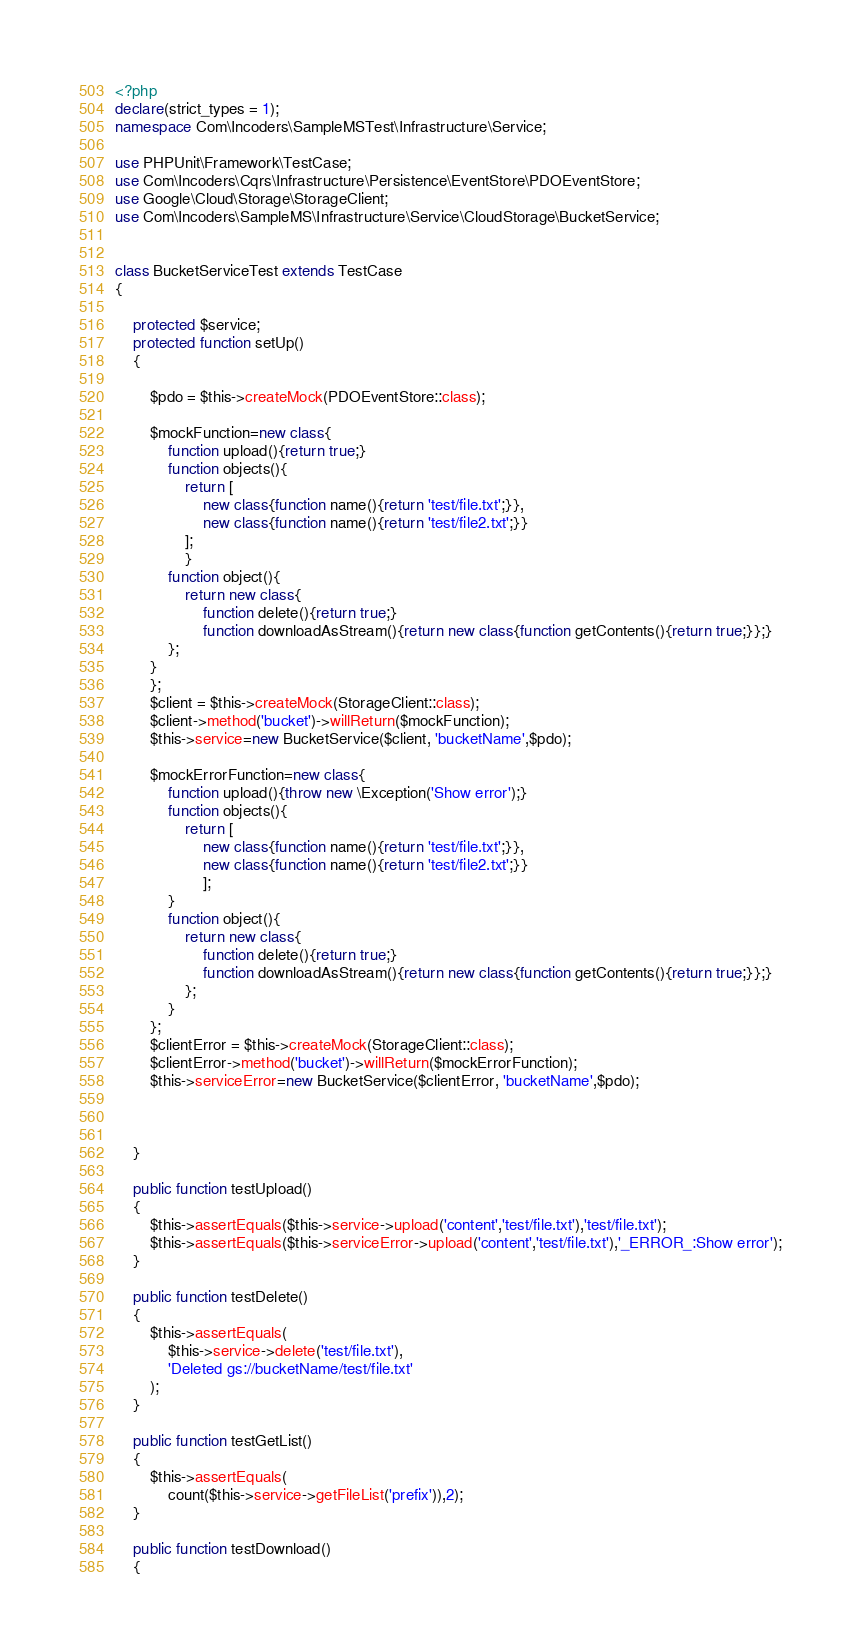<code> <loc_0><loc_0><loc_500><loc_500><_PHP_><?php
declare(strict_types = 1);
namespace Com\Incoders\SampleMSTest\Infrastructure\Service;

use PHPUnit\Framework\TestCase;
use Com\Incoders\Cqrs\Infrastructure\Persistence\EventStore\PDOEventStore;
use Google\Cloud\Storage\StorageClient;
use Com\Incoders\SampleMS\Infrastructure\Service\CloudStorage\BucketService;


class BucketServiceTest extends TestCase
{

    protected $service;
    protected function setUp()
    {

        $pdo = $this->createMock(PDOEventStore::class);

        $mockFunction=new class{
            function upload(){return true;}
            function objects(){
                return [
                    new class{function name(){return 'test/file.txt';}},
                    new class{function name(){return 'test/file2.txt';}}
                ];
                }
            function object(){
                return new class{
                    function delete(){return true;}
                    function downloadAsStream(){return new class{function getContents(){return true;}};}
            };
        }
        };
        $client = $this->createMock(StorageClient::class);
        $client->method('bucket')->willReturn($mockFunction);
        $this->service=new BucketService($client, 'bucketName',$pdo);
        
        $mockErrorFunction=new class{
            function upload(){throw new \Exception('Show error');}
            function objects(){
                return [
                    new class{function name(){return 'test/file.txt';}},
                    new class{function name(){return 'test/file2.txt';}}
                    ];
            }
            function object(){
                return new class{
                    function delete(){return true;}
                    function downloadAsStream(){return new class{function getContents(){return true;}};}
                };
            }
        };
        $clientError = $this->createMock(StorageClient::class);
        $clientError->method('bucket')->willReturn($mockErrorFunction);
        $this->serviceError=new BucketService($clientError, 'bucketName',$pdo);

        
        
    }

    public function testUpload()
    {
        $this->assertEquals($this->service->upload('content','test/file.txt'),'test/file.txt');
        $this->assertEquals($this->serviceError->upload('content','test/file.txt'),'_ERROR_:Show error');
    }

    public function testDelete()
    {
        $this->assertEquals(
            $this->service->delete('test/file.txt'),
            'Deleted gs://bucketName/test/file.txt'
        );
    }

    public function testGetList()
    {
        $this->assertEquals(
            count($this->service->getFileList('prefix')),2);
    }

    public function testDownload()
    {</code> 